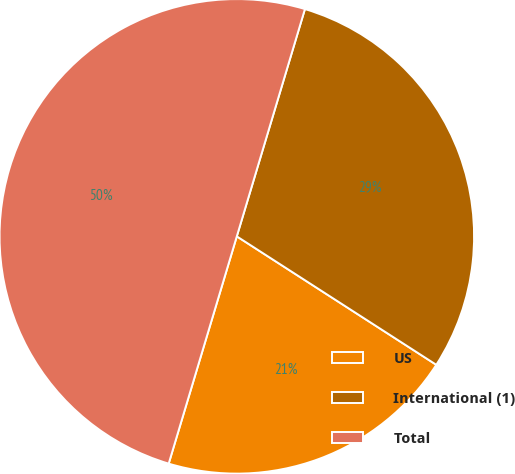Convert chart to OTSL. <chart><loc_0><loc_0><loc_500><loc_500><pie_chart><fcel>US<fcel>International (1)<fcel>Total<nl><fcel>20.53%<fcel>29.47%<fcel>50.0%<nl></chart> 